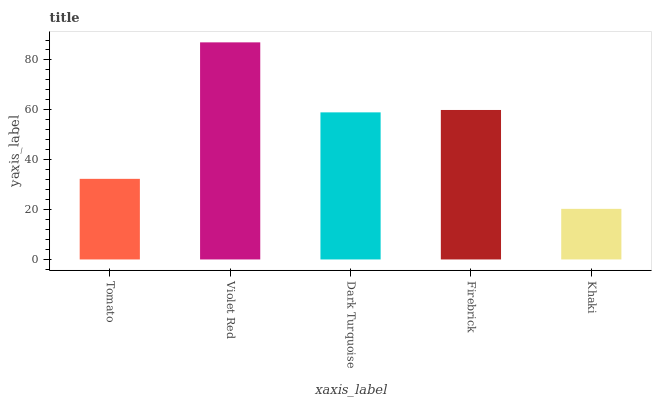Is Khaki the minimum?
Answer yes or no. Yes. Is Violet Red the maximum?
Answer yes or no. Yes. Is Dark Turquoise the minimum?
Answer yes or no. No. Is Dark Turquoise the maximum?
Answer yes or no. No. Is Violet Red greater than Dark Turquoise?
Answer yes or no. Yes. Is Dark Turquoise less than Violet Red?
Answer yes or no. Yes. Is Dark Turquoise greater than Violet Red?
Answer yes or no. No. Is Violet Red less than Dark Turquoise?
Answer yes or no. No. Is Dark Turquoise the high median?
Answer yes or no. Yes. Is Dark Turquoise the low median?
Answer yes or no. Yes. Is Tomato the high median?
Answer yes or no. No. Is Tomato the low median?
Answer yes or no. No. 